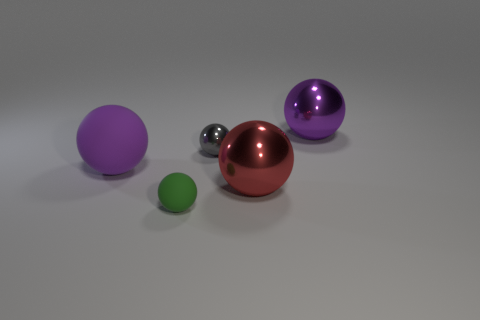Is there a brown cube that has the same material as the green ball?
Offer a very short reply. No. Are the large purple ball on the left side of the purple metallic sphere and the small green object made of the same material?
Ensure brevity in your answer.  Yes. Is the number of big purple shiny objects on the left side of the purple rubber ball greater than the number of tiny things right of the gray metal object?
Offer a terse response. No. The rubber object that is the same size as the purple metal object is what color?
Give a very brief answer. Purple. Are there any small matte things of the same color as the tiny metallic thing?
Your answer should be compact. No. There is a small thing in front of the red shiny sphere; is its color the same as the rubber ball that is behind the green matte thing?
Make the answer very short. No. There is a object left of the green rubber thing; what is its material?
Give a very brief answer. Rubber. The tiny thing that is made of the same material as the red ball is what color?
Your answer should be compact. Gray. How many metallic balls have the same size as the red metallic thing?
Ensure brevity in your answer.  1. Does the metallic ball that is on the left side of the red metal sphere have the same size as the red metallic ball?
Ensure brevity in your answer.  No. 